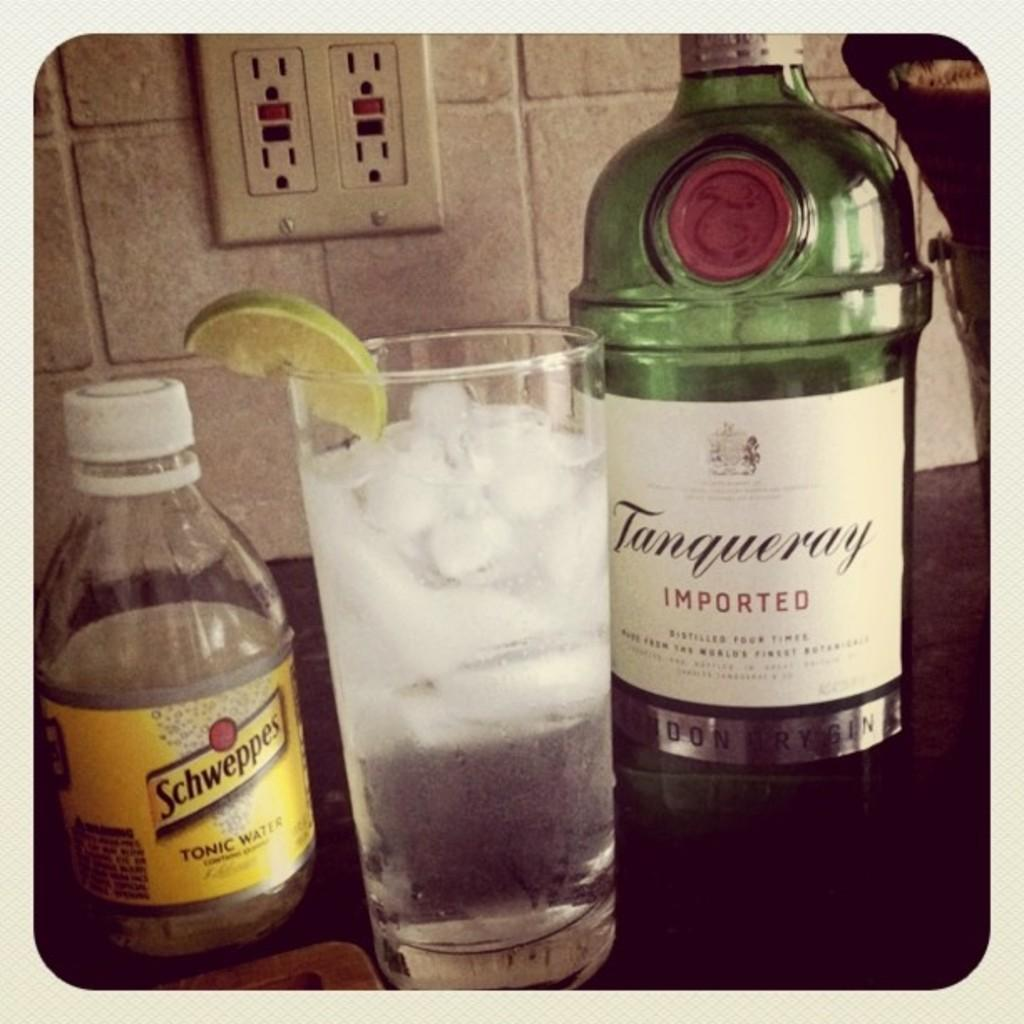<image>
Provide a brief description of the given image. the word imported is on the back of a wine bottle 